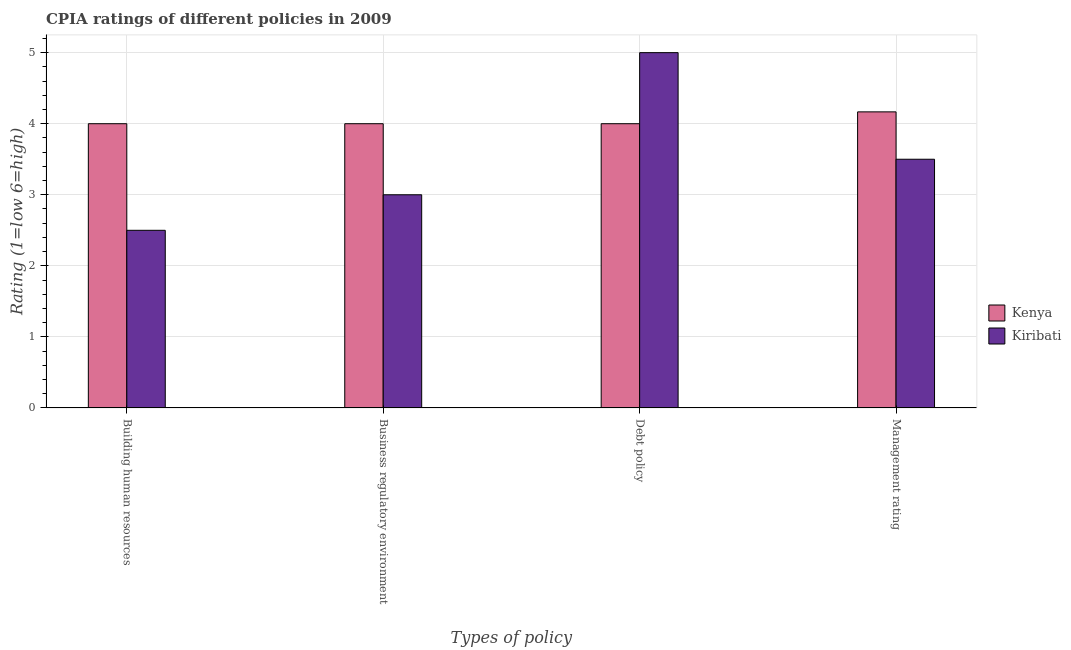How many different coloured bars are there?
Provide a short and direct response. 2. Are the number of bars per tick equal to the number of legend labels?
Ensure brevity in your answer.  Yes. What is the label of the 2nd group of bars from the left?
Your answer should be compact. Business regulatory environment. What is the cpia rating of debt policy in Kiribati?
Ensure brevity in your answer.  5. Across all countries, what is the maximum cpia rating of business regulatory environment?
Give a very brief answer. 4. In which country was the cpia rating of debt policy maximum?
Ensure brevity in your answer.  Kiribati. In which country was the cpia rating of business regulatory environment minimum?
Offer a terse response. Kiribati. What is the total cpia rating of management in the graph?
Offer a terse response. 7.67. What is the difference between the cpia rating of building human resources and cpia rating of management in Kiribati?
Provide a succinct answer. -1. What is the ratio of the cpia rating of business regulatory environment in Kenya to that in Kiribati?
Your response must be concise. 1.33. Is the cpia rating of building human resources in Kiribati less than that in Kenya?
Your answer should be compact. Yes. What is the difference between the highest and the second highest cpia rating of management?
Make the answer very short. 0.67. In how many countries, is the cpia rating of management greater than the average cpia rating of management taken over all countries?
Provide a succinct answer. 1. Is it the case that in every country, the sum of the cpia rating of management and cpia rating of debt policy is greater than the sum of cpia rating of building human resources and cpia rating of business regulatory environment?
Provide a succinct answer. No. What does the 2nd bar from the left in Management rating represents?
Give a very brief answer. Kiribati. What does the 2nd bar from the right in Business regulatory environment represents?
Offer a very short reply. Kenya. Are all the bars in the graph horizontal?
Your answer should be very brief. No. Are the values on the major ticks of Y-axis written in scientific E-notation?
Your response must be concise. No. Does the graph contain any zero values?
Give a very brief answer. No. Where does the legend appear in the graph?
Give a very brief answer. Center right. What is the title of the graph?
Keep it short and to the point. CPIA ratings of different policies in 2009. Does "El Salvador" appear as one of the legend labels in the graph?
Give a very brief answer. No. What is the label or title of the X-axis?
Your answer should be compact. Types of policy. What is the Rating (1=low 6=high) in Kenya in Building human resources?
Offer a terse response. 4. What is the Rating (1=low 6=high) of Kiribati in Building human resources?
Keep it short and to the point. 2.5. What is the Rating (1=low 6=high) of Kenya in Business regulatory environment?
Offer a terse response. 4. What is the Rating (1=low 6=high) in Kiribati in Business regulatory environment?
Offer a terse response. 3. What is the Rating (1=low 6=high) of Kenya in Debt policy?
Your response must be concise. 4. What is the Rating (1=low 6=high) of Kenya in Management rating?
Provide a succinct answer. 4.17. Across all Types of policy, what is the maximum Rating (1=low 6=high) of Kenya?
Keep it short and to the point. 4.17. Across all Types of policy, what is the maximum Rating (1=low 6=high) in Kiribati?
Your answer should be compact. 5. What is the total Rating (1=low 6=high) in Kenya in the graph?
Your response must be concise. 16.17. What is the difference between the Rating (1=low 6=high) of Kenya in Building human resources and that in Business regulatory environment?
Provide a short and direct response. 0. What is the difference between the Rating (1=low 6=high) of Kenya in Business regulatory environment and that in Debt policy?
Keep it short and to the point. 0. What is the difference between the Rating (1=low 6=high) in Kiribati in Business regulatory environment and that in Debt policy?
Keep it short and to the point. -2. What is the difference between the Rating (1=low 6=high) of Kenya in Debt policy and that in Management rating?
Offer a very short reply. -0.17. What is the difference between the Rating (1=low 6=high) in Kiribati in Debt policy and that in Management rating?
Provide a succinct answer. 1.5. What is the difference between the Rating (1=low 6=high) in Kenya in Building human resources and the Rating (1=low 6=high) in Kiribati in Business regulatory environment?
Ensure brevity in your answer.  1. What is the difference between the Rating (1=low 6=high) in Kenya in Building human resources and the Rating (1=low 6=high) in Kiribati in Debt policy?
Offer a terse response. -1. What is the difference between the Rating (1=low 6=high) of Kenya in Business regulatory environment and the Rating (1=low 6=high) of Kiribati in Debt policy?
Your answer should be very brief. -1. What is the difference between the Rating (1=low 6=high) in Kenya in Business regulatory environment and the Rating (1=low 6=high) in Kiribati in Management rating?
Provide a short and direct response. 0.5. What is the difference between the Rating (1=low 6=high) of Kenya in Debt policy and the Rating (1=low 6=high) of Kiribati in Management rating?
Your response must be concise. 0.5. What is the average Rating (1=low 6=high) in Kenya per Types of policy?
Your answer should be compact. 4.04. What is the difference between the Rating (1=low 6=high) in Kenya and Rating (1=low 6=high) in Kiribati in Building human resources?
Provide a succinct answer. 1.5. What is the difference between the Rating (1=low 6=high) of Kenya and Rating (1=low 6=high) of Kiribati in Management rating?
Provide a succinct answer. 0.67. What is the ratio of the Rating (1=low 6=high) of Kenya in Building human resources to that in Business regulatory environment?
Your response must be concise. 1. What is the ratio of the Rating (1=low 6=high) of Kiribati in Building human resources to that in Debt policy?
Give a very brief answer. 0.5. What is the ratio of the Rating (1=low 6=high) of Kenya in Building human resources to that in Management rating?
Make the answer very short. 0.96. What is the ratio of the Rating (1=low 6=high) in Kiribati in Building human resources to that in Management rating?
Keep it short and to the point. 0.71. What is the ratio of the Rating (1=low 6=high) in Kenya in Business regulatory environment to that in Debt policy?
Your answer should be compact. 1. What is the ratio of the Rating (1=low 6=high) in Kiribati in Business regulatory environment to that in Management rating?
Offer a very short reply. 0.86. What is the ratio of the Rating (1=low 6=high) in Kiribati in Debt policy to that in Management rating?
Your answer should be very brief. 1.43. What is the difference between the highest and the second highest Rating (1=low 6=high) of Kenya?
Your response must be concise. 0.17. What is the difference between the highest and the lowest Rating (1=low 6=high) of Kiribati?
Make the answer very short. 2.5. 